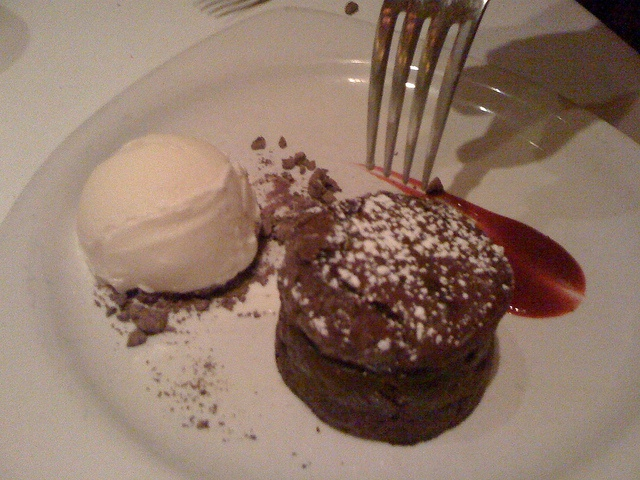Describe the objects in this image and their specific colors. I can see cake in gray, maroon, and black tones, fork in gray, maroon, and black tones, and fork in gray tones in this image. 